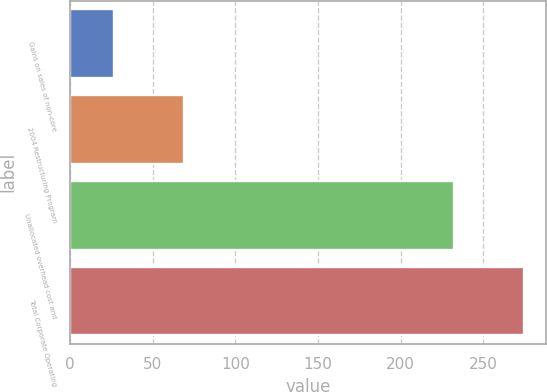Convert chart to OTSL. <chart><loc_0><loc_0><loc_500><loc_500><bar_chart><fcel>Gains on sales of non-core<fcel>2004 Restructuring Program<fcel>Unallocated overhead cost and<fcel>Total Corporate Operating<nl><fcel>26.7<fcel>68.7<fcel>232.5<fcel>274.5<nl></chart> 